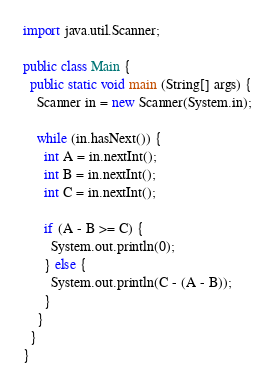Convert code to text. <code><loc_0><loc_0><loc_500><loc_500><_Java_>import java.util.Scanner;

public class Main {
  public static void main (String[] args) {
    Scanner in = new Scanner(System.in);

    while (in.hasNext()) {
      int A = in.nextInt();
      int B = in.nextInt();
      int C = in.nextInt();

      if (A - B >= C) {
        System.out.println(0);
      } else {
        System.out.println(C - (A - B));
      }
    }
  }
}</code> 